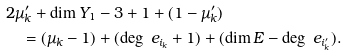Convert formula to latex. <formula><loc_0><loc_0><loc_500><loc_500>& 2 \mu ^ { \prime } _ { k } + \dim Y _ { 1 } - 3 + 1 + ( 1 - \mu ^ { \prime } _ { k } ) \\ & \quad = ( \mu _ { k } - 1 ) + ( \deg \ e _ { i _ { k } } + 1 ) + ( \dim E - \deg \ e _ { i ^ { \prime } _ { k } } ) .</formula> 